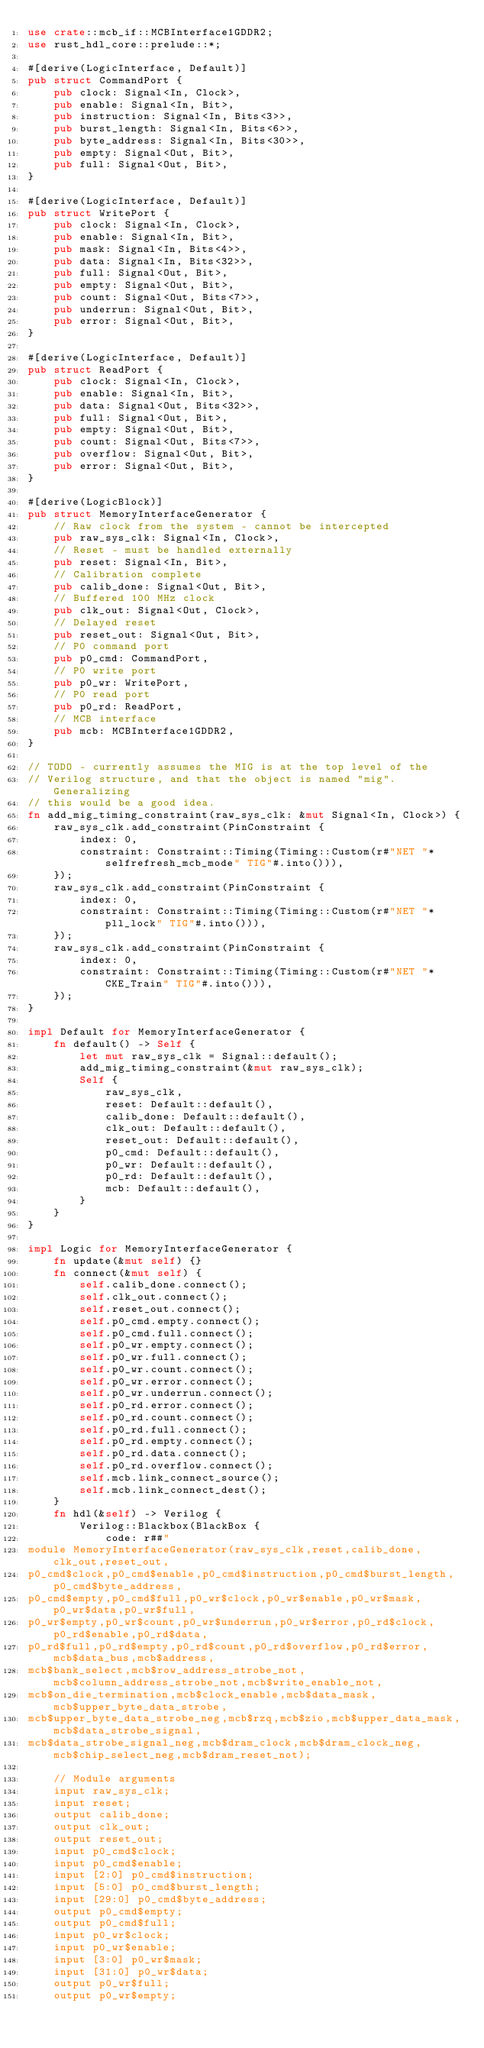<code> <loc_0><loc_0><loc_500><loc_500><_Rust_>use crate::mcb_if::MCBInterface1GDDR2;
use rust_hdl_core::prelude::*;

#[derive(LogicInterface, Default)]
pub struct CommandPort {
    pub clock: Signal<In, Clock>,
    pub enable: Signal<In, Bit>,
    pub instruction: Signal<In, Bits<3>>,
    pub burst_length: Signal<In, Bits<6>>,
    pub byte_address: Signal<In, Bits<30>>,
    pub empty: Signal<Out, Bit>,
    pub full: Signal<Out, Bit>,
}

#[derive(LogicInterface, Default)]
pub struct WritePort {
    pub clock: Signal<In, Clock>,
    pub enable: Signal<In, Bit>,
    pub mask: Signal<In, Bits<4>>,
    pub data: Signal<In, Bits<32>>,
    pub full: Signal<Out, Bit>,
    pub empty: Signal<Out, Bit>,
    pub count: Signal<Out, Bits<7>>,
    pub underrun: Signal<Out, Bit>,
    pub error: Signal<Out, Bit>,
}

#[derive(LogicInterface, Default)]
pub struct ReadPort {
    pub clock: Signal<In, Clock>,
    pub enable: Signal<In, Bit>,
    pub data: Signal<Out, Bits<32>>,
    pub full: Signal<Out, Bit>,
    pub empty: Signal<Out, Bit>,
    pub count: Signal<Out, Bits<7>>,
    pub overflow: Signal<Out, Bit>,
    pub error: Signal<Out, Bit>,
}

#[derive(LogicBlock)]
pub struct MemoryInterfaceGenerator {
    // Raw clock from the system - cannot be intercepted
    pub raw_sys_clk: Signal<In, Clock>,
    // Reset - must be handled externally
    pub reset: Signal<In, Bit>,
    // Calibration complete
    pub calib_done: Signal<Out, Bit>,
    // Buffered 100 MHz clock
    pub clk_out: Signal<Out, Clock>,
    // Delayed reset
    pub reset_out: Signal<Out, Bit>,
    // P0 command port
    pub p0_cmd: CommandPort,
    // P0 write port
    pub p0_wr: WritePort,
    // P0 read port
    pub p0_rd: ReadPort,
    // MCB interface
    pub mcb: MCBInterface1GDDR2,
}

// TODO - currently assumes the MIG is at the top level of the
// Verilog structure, and that the object is named "mig".  Generalizing
// this would be a good idea.
fn add_mig_timing_constraint(raw_sys_clk: &mut Signal<In, Clock>) {
    raw_sys_clk.add_constraint(PinConstraint {
        index: 0,
        constraint: Constraint::Timing(Timing::Custom(r#"NET "*selfrefresh_mcb_mode" TIG"#.into())),
    });
    raw_sys_clk.add_constraint(PinConstraint {
        index: 0,
        constraint: Constraint::Timing(Timing::Custom(r#"NET "*pll_lock" TIG"#.into())),
    });
    raw_sys_clk.add_constraint(PinConstraint {
        index: 0,
        constraint: Constraint::Timing(Timing::Custom(r#"NET "*CKE_Train" TIG"#.into())),
    });
}

impl Default for MemoryInterfaceGenerator {
    fn default() -> Self {
        let mut raw_sys_clk = Signal::default();
        add_mig_timing_constraint(&mut raw_sys_clk);
        Self {
            raw_sys_clk,
            reset: Default::default(),
            calib_done: Default::default(),
            clk_out: Default::default(),
            reset_out: Default::default(),
            p0_cmd: Default::default(),
            p0_wr: Default::default(),
            p0_rd: Default::default(),
            mcb: Default::default(),
        }
    }
}

impl Logic for MemoryInterfaceGenerator {
    fn update(&mut self) {}
    fn connect(&mut self) {
        self.calib_done.connect();
        self.clk_out.connect();
        self.reset_out.connect();
        self.p0_cmd.empty.connect();
        self.p0_cmd.full.connect();
        self.p0_wr.empty.connect();
        self.p0_wr.full.connect();
        self.p0_wr.count.connect();
        self.p0_wr.error.connect();
        self.p0_wr.underrun.connect();
        self.p0_rd.error.connect();
        self.p0_rd.count.connect();
        self.p0_rd.full.connect();
        self.p0_rd.empty.connect();
        self.p0_rd.data.connect();
        self.p0_rd.overflow.connect();
        self.mcb.link_connect_source();
        self.mcb.link_connect_dest();
    }
    fn hdl(&self) -> Verilog {
        Verilog::Blackbox(BlackBox {
            code: r##"
module MemoryInterfaceGenerator(raw_sys_clk,reset,calib_done,clk_out,reset_out,
p0_cmd$clock,p0_cmd$enable,p0_cmd$instruction,p0_cmd$burst_length,p0_cmd$byte_address,
p0_cmd$empty,p0_cmd$full,p0_wr$clock,p0_wr$enable,p0_wr$mask,p0_wr$data,p0_wr$full,
p0_wr$empty,p0_wr$count,p0_wr$underrun,p0_wr$error,p0_rd$clock,p0_rd$enable,p0_rd$data,
p0_rd$full,p0_rd$empty,p0_rd$count,p0_rd$overflow,p0_rd$error,mcb$data_bus,mcb$address,
mcb$bank_select,mcb$row_address_strobe_not,mcb$column_address_strobe_not,mcb$write_enable_not,
mcb$on_die_termination,mcb$clock_enable,mcb$data_mask,mcb$upper_byte_data_strobe,
mcb$upper_byte_data_strobe_neg,mcb$rzq,mcb$zio,mcb$upper_data_mask,mcb$data_strobe_signal,
mcb$data_strobe_signal_neg,mcb$dram_clock,mcb$dram_clock_neg,mcb$chip_select_neg,mcb$dram_reset_not);

    // Module arguments
    input raw_sys_clk;
    input reset;
    output calib_done;
    output clk_out;
    output reset_out;
    input p0_cmd$clock;
    input p0_cmd$enable;
    input [2:0] p0_cmd$instruction;
    input [5:0] p0_cmd$burst_length;
    input [29:0] p0_cmd$byte_address;
    output p0_cmd$empty;
    output p0_cmd$full;
    input p0_wr$clock;
    input p0_wr$enable;
    input [3:0] p0_wr$mask;
    input [31:0] p0_wr$data;
    output p0_wr$full;
    output p0_wr$empty;</code> 